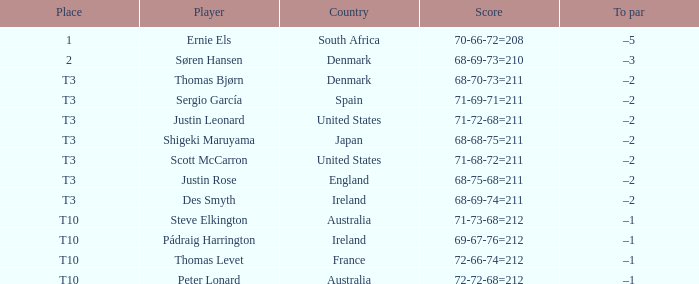Which player achieved a score of 71-69-71, totaling 211? Sergio García. 